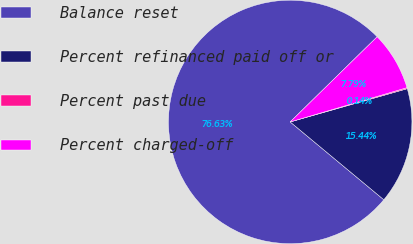Convert chart to OTSL. <chart><loc_0><loc_0><loc_500><loc_500><pie_chart><fcel>Balance reset<fcel>Percent refinanced paid off or<fcel>Percent past due<fcel>Percent charged-off<nl><fcel>76.64%<fcel>15.44%<fcel>0.14%<fcel>7.79%<nl></chart> 